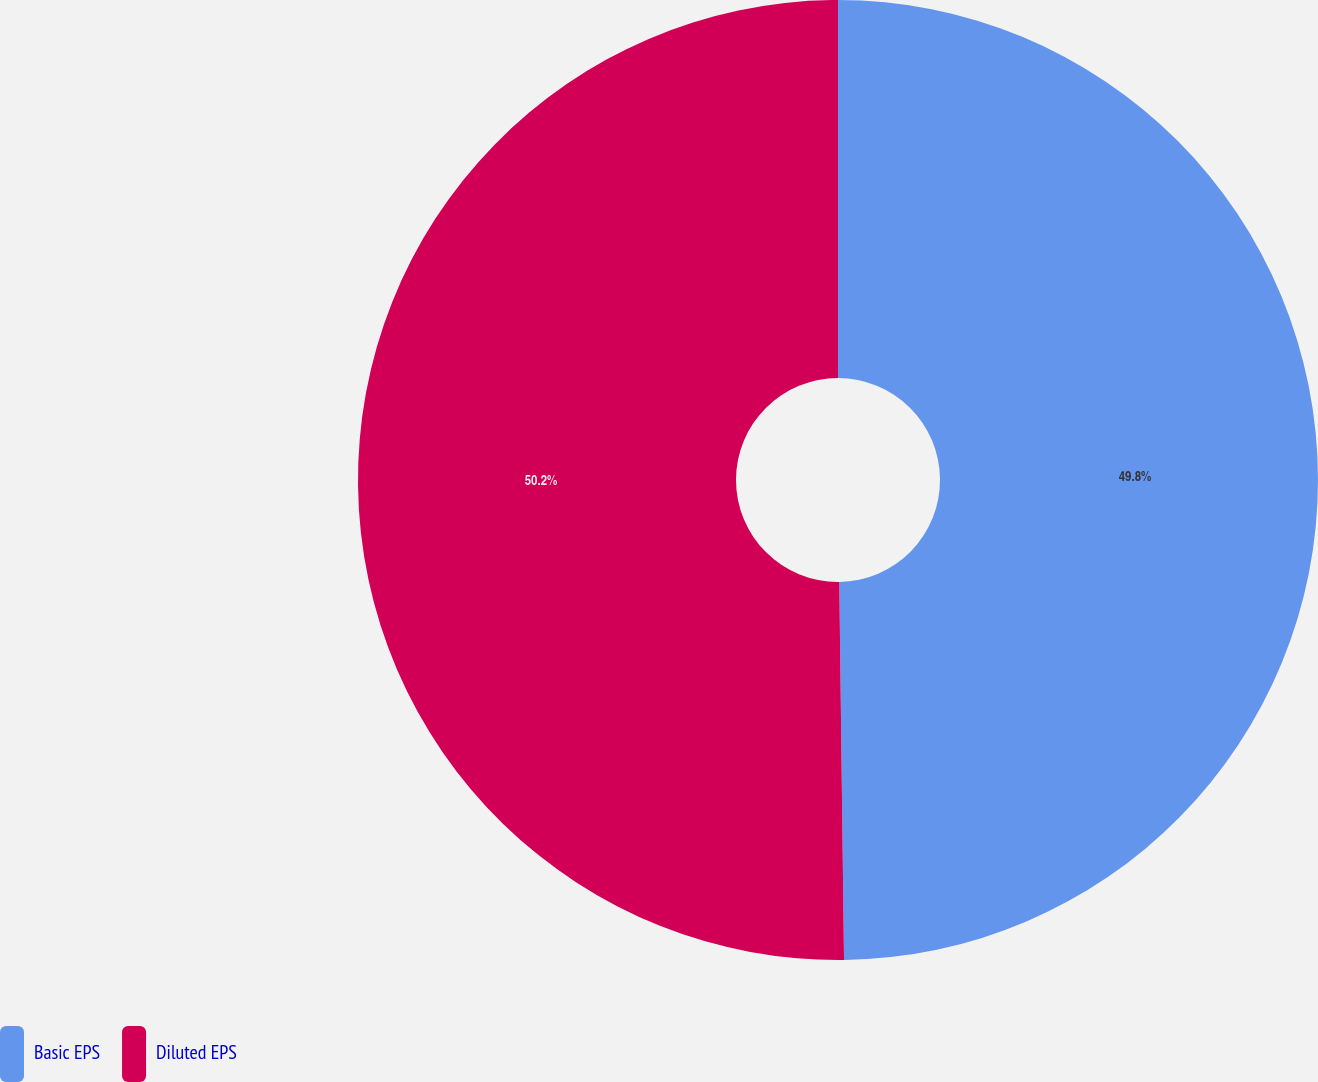<chart> <loc_0><loc_0><loc_500><loc_500><pie_chart><fcel>Basic EPS<fcel>Diluted EPS<nl><fcel>49.8%<fcel>50.2%<nl></chart> 